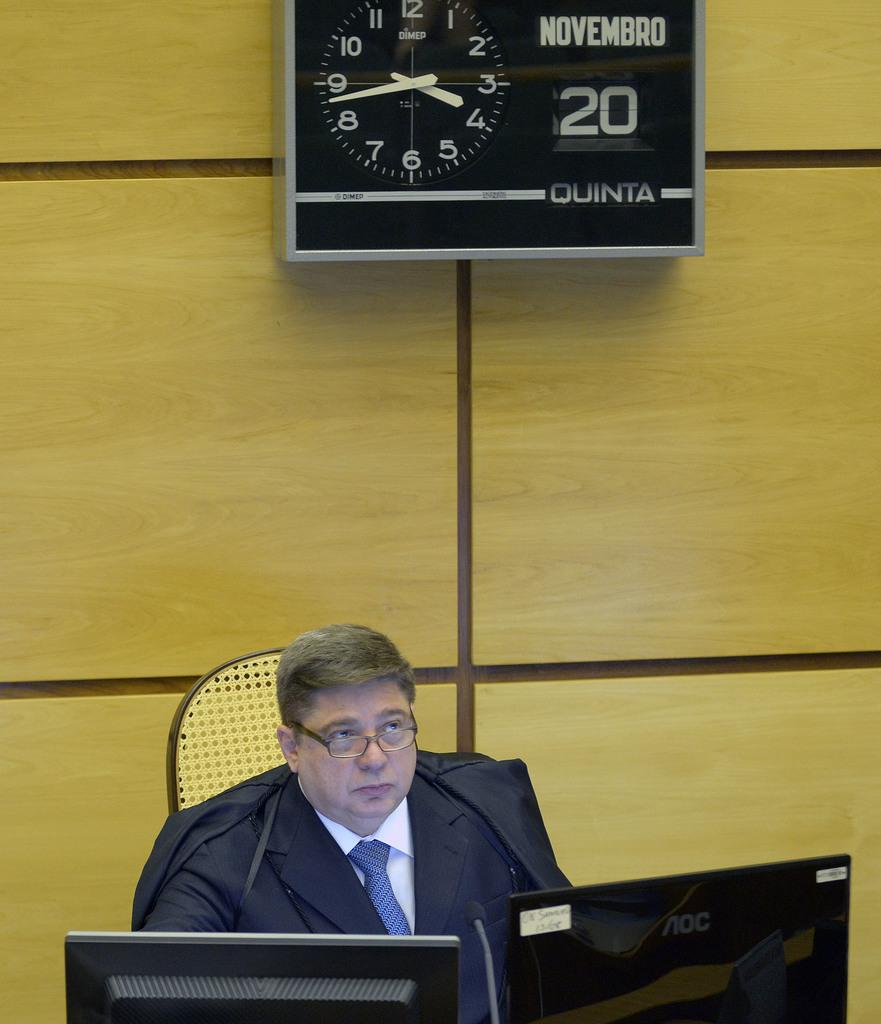<image>
Write a terse but informative summary of the picture. A clock on the wall shows that it is the 20th of November. 